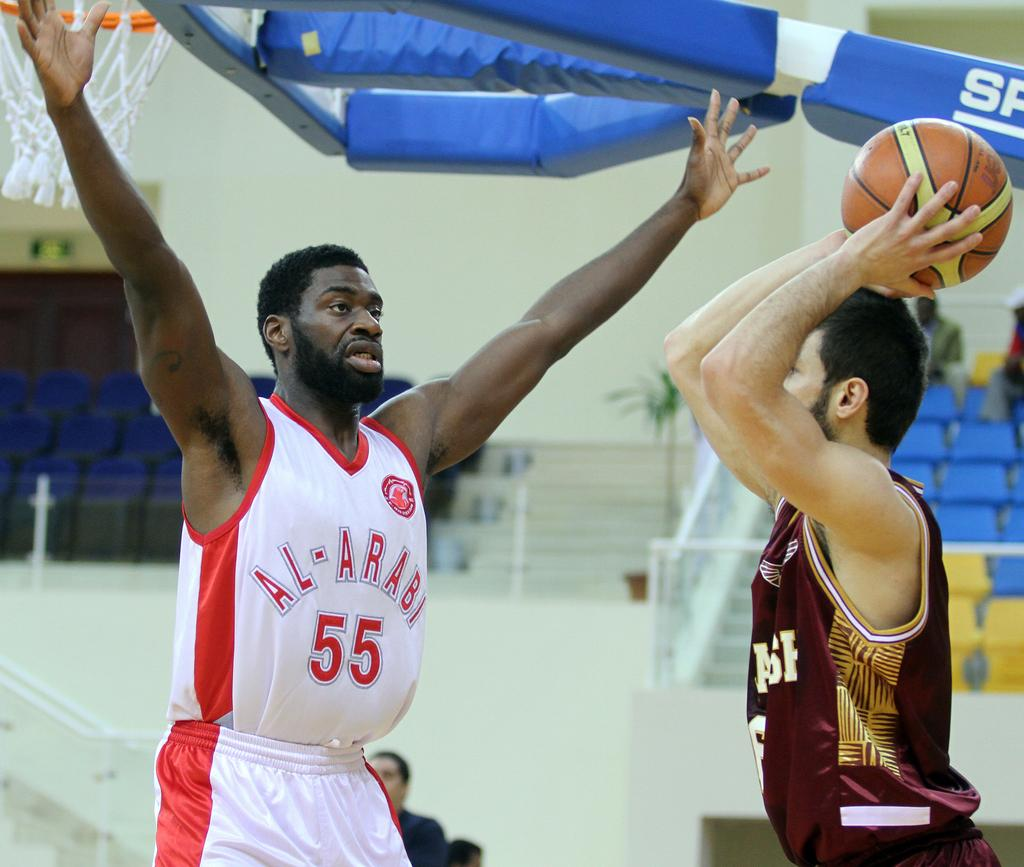<image>
Summarize the visual content of the image. A man in marroon attempts to throw a ball near a player wearing number 55. 